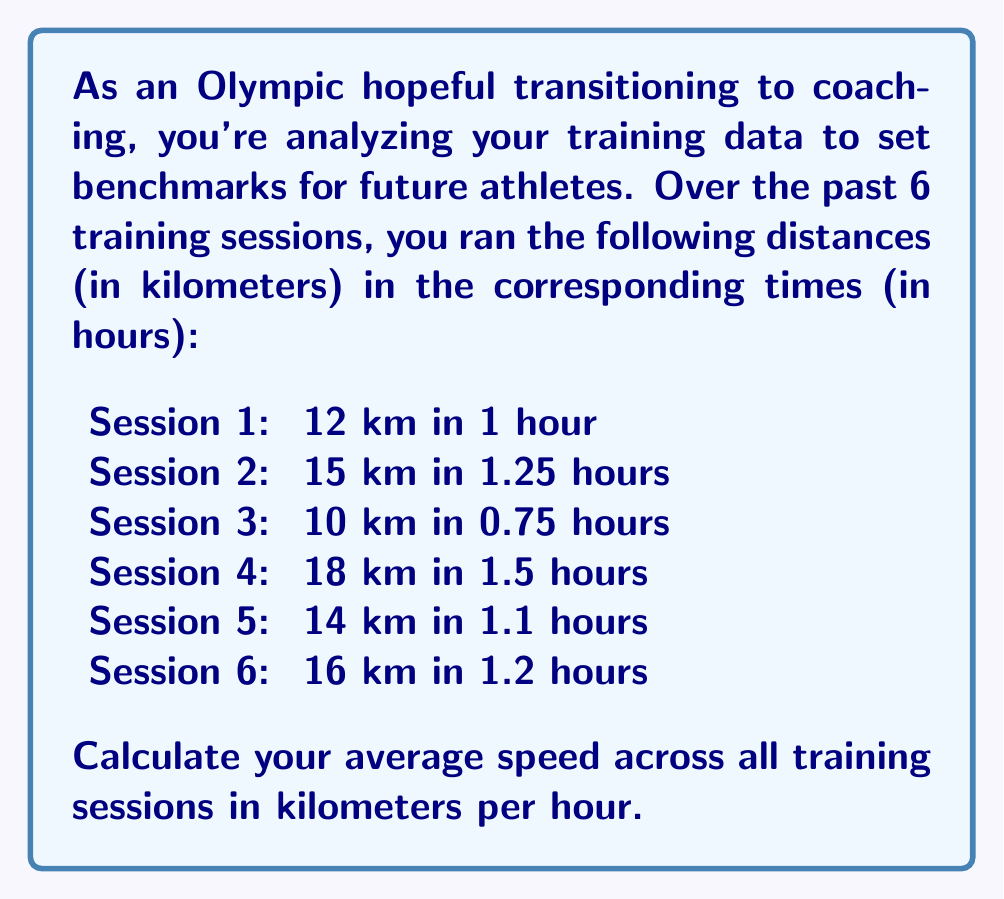Solve this math problem. To calculate the average speed across all training sessions, we need to follow these steps:

1. Calculate the total distance covered:
   $$ \text{Total Distance} = 12 + 15 + 10 + 18 + 14 + 16 = 85 \text{ km} $$

2. Calculate the total time spent:
   $$ \text{Total Time} = 1 + 1.25 + 0.75 + 1.5 + 1.1 + 1.2 = 6.8 \text{ hours} $$

3. Use the formula for average speed:
   $$ \text{Average Speed} = \frac{\text{Total Distance}}{\text{Total Time}} $$

4. Substitute the values and calculate:
   $$ \text{Average Speed} = \frac{85 \text{ km}}{6.8 \text{ hours}} \approx 12.5 \text{ km/h} $$

The result is rounded to one decimal place for practical use in coaching.
Answer: $12.5 \text{ km/h}$ 